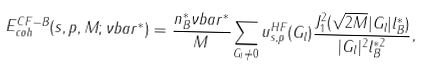Convert formula to latex. <formula><loc_0><loc_0><loc_500><loc_500>E _ { c o h } ^ { C F - B } ( s , p , M ; \nu b a r ^ { * } ) = \frac { n _ { B } ^ { * } \nu b a r ^ { * } } { M } \sum _ { { G } _ { l } \neq 0 } u _ { s , p } ^ { H F } ( { G } _ { l } ) \frac { J _ { 1 } ^ { 2 } ( \sqrt { 2 M } | { G } _ { l } | l _ { B } ^ { * } ) } { | { G } _ { l } | ^ { 2 } l _ { B } ^ { * 2 } } ,</formula> 